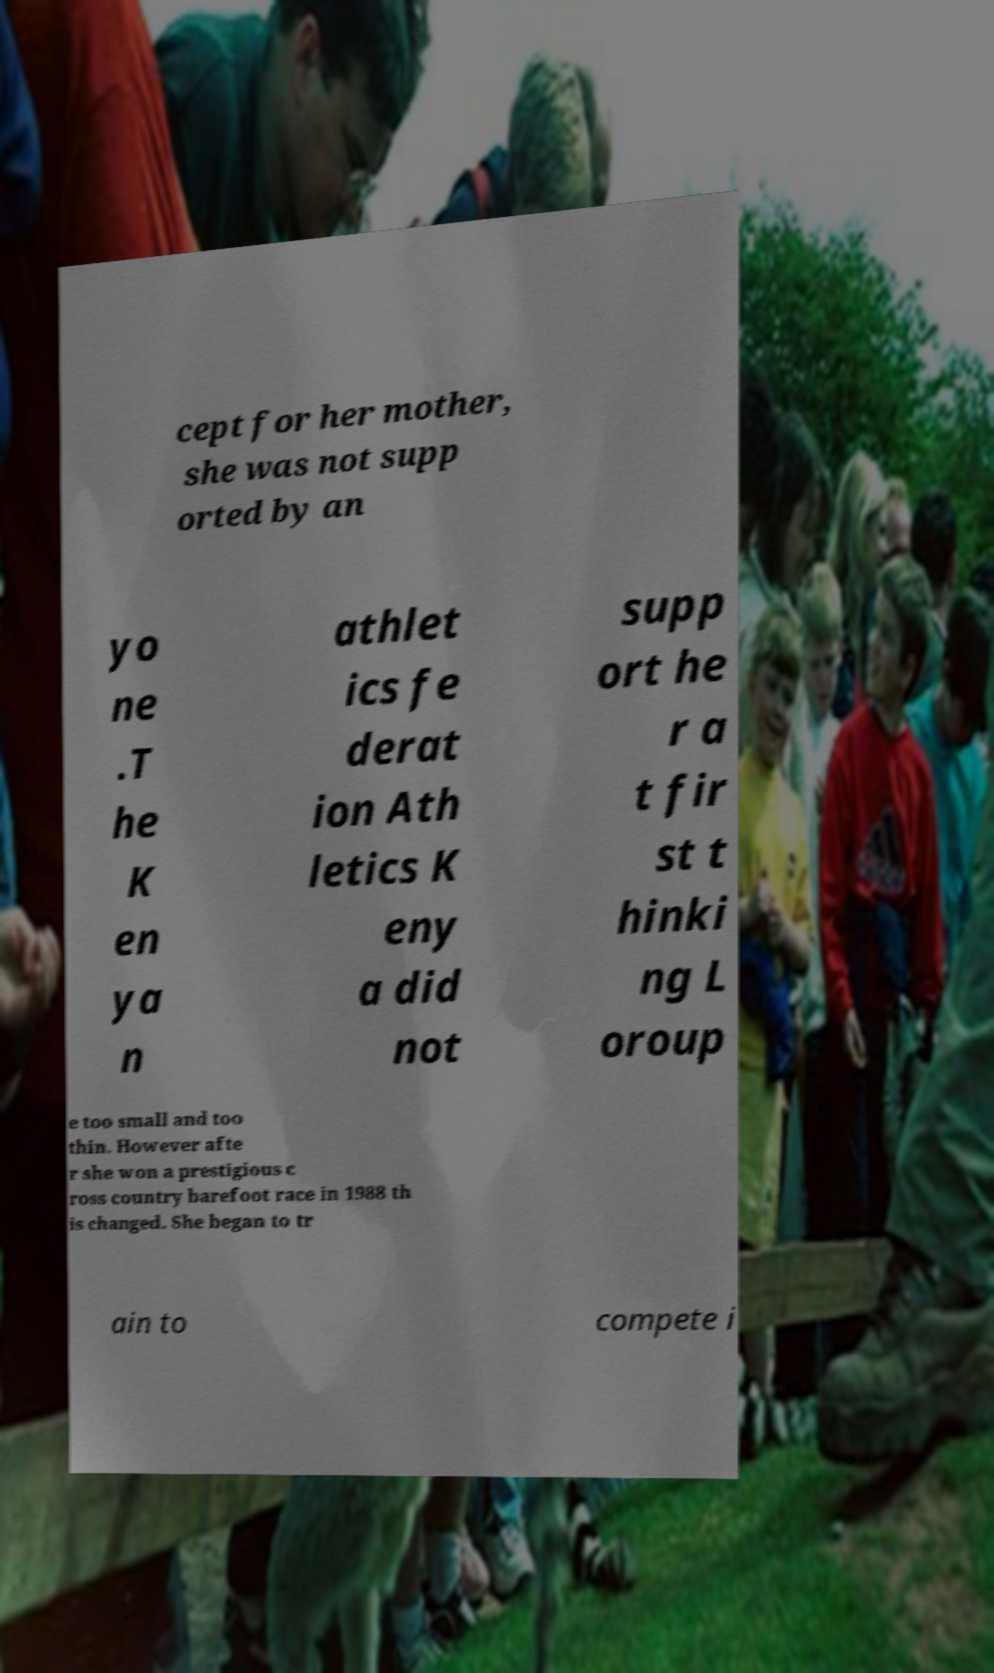Could you extract and type out the text from this image? cept for her mother, she was not supp orted by an yo ne .T he K en ya n athlet ics fe derat ion Ath letics K eny a did not supp ort he r a t fir st t hinki ng L oroup e too small and too thin. However afte r she won a prestigious c ross country barefoot race in 1988 th is changed. She began to tr ain to compete i 